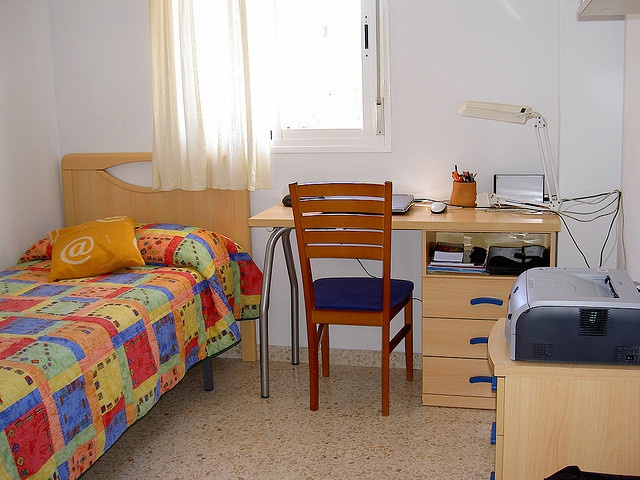Describe the objects in this image and their specific colors. I can see bed in darkgray, olive, salmon, tan, and brown tones, chair in darkgray, maroon, and black tones, handbag in darkgray, black, and gray tones, laptop in darkgray, lightgray, and black tones, and book in darkgray, gray, black, and maroon tones in this image. 